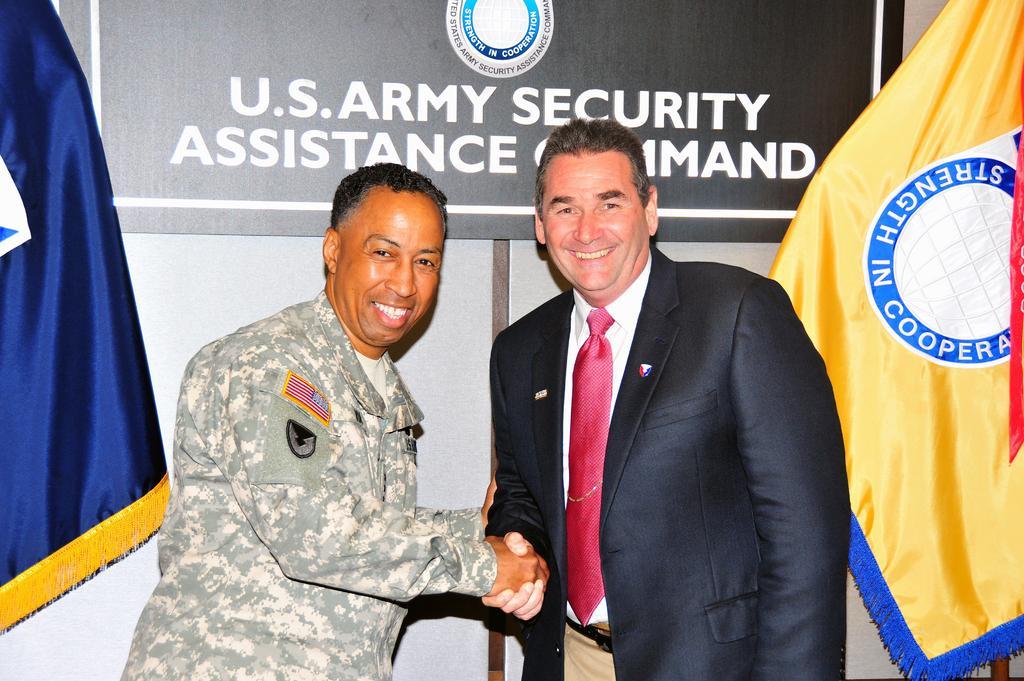Could you give a brief overview of what you see in this image? In the center of the image there are two men standing on the floor. In the background there is a board and flags. 